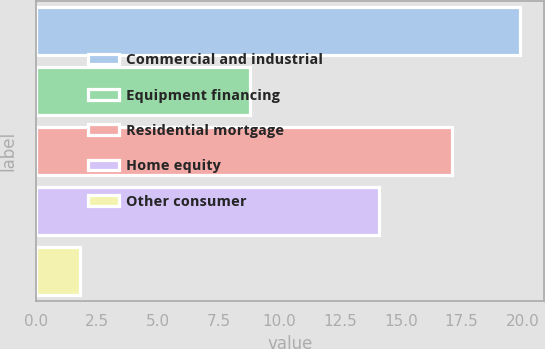Convert chart to OTSL. <chart><loc_0><loc_0><loc_500><loc_500><bar_chart><fcel>Commercial and industrial<fcel>Equipment financing<fcel>Residential mortgage<fcel>Home equity<fcel>Other consumer<nl><fcel>19.9<fcel>8.8<fcel>17.1<fcel>14.1<fcel>1.8<nl></chart> 